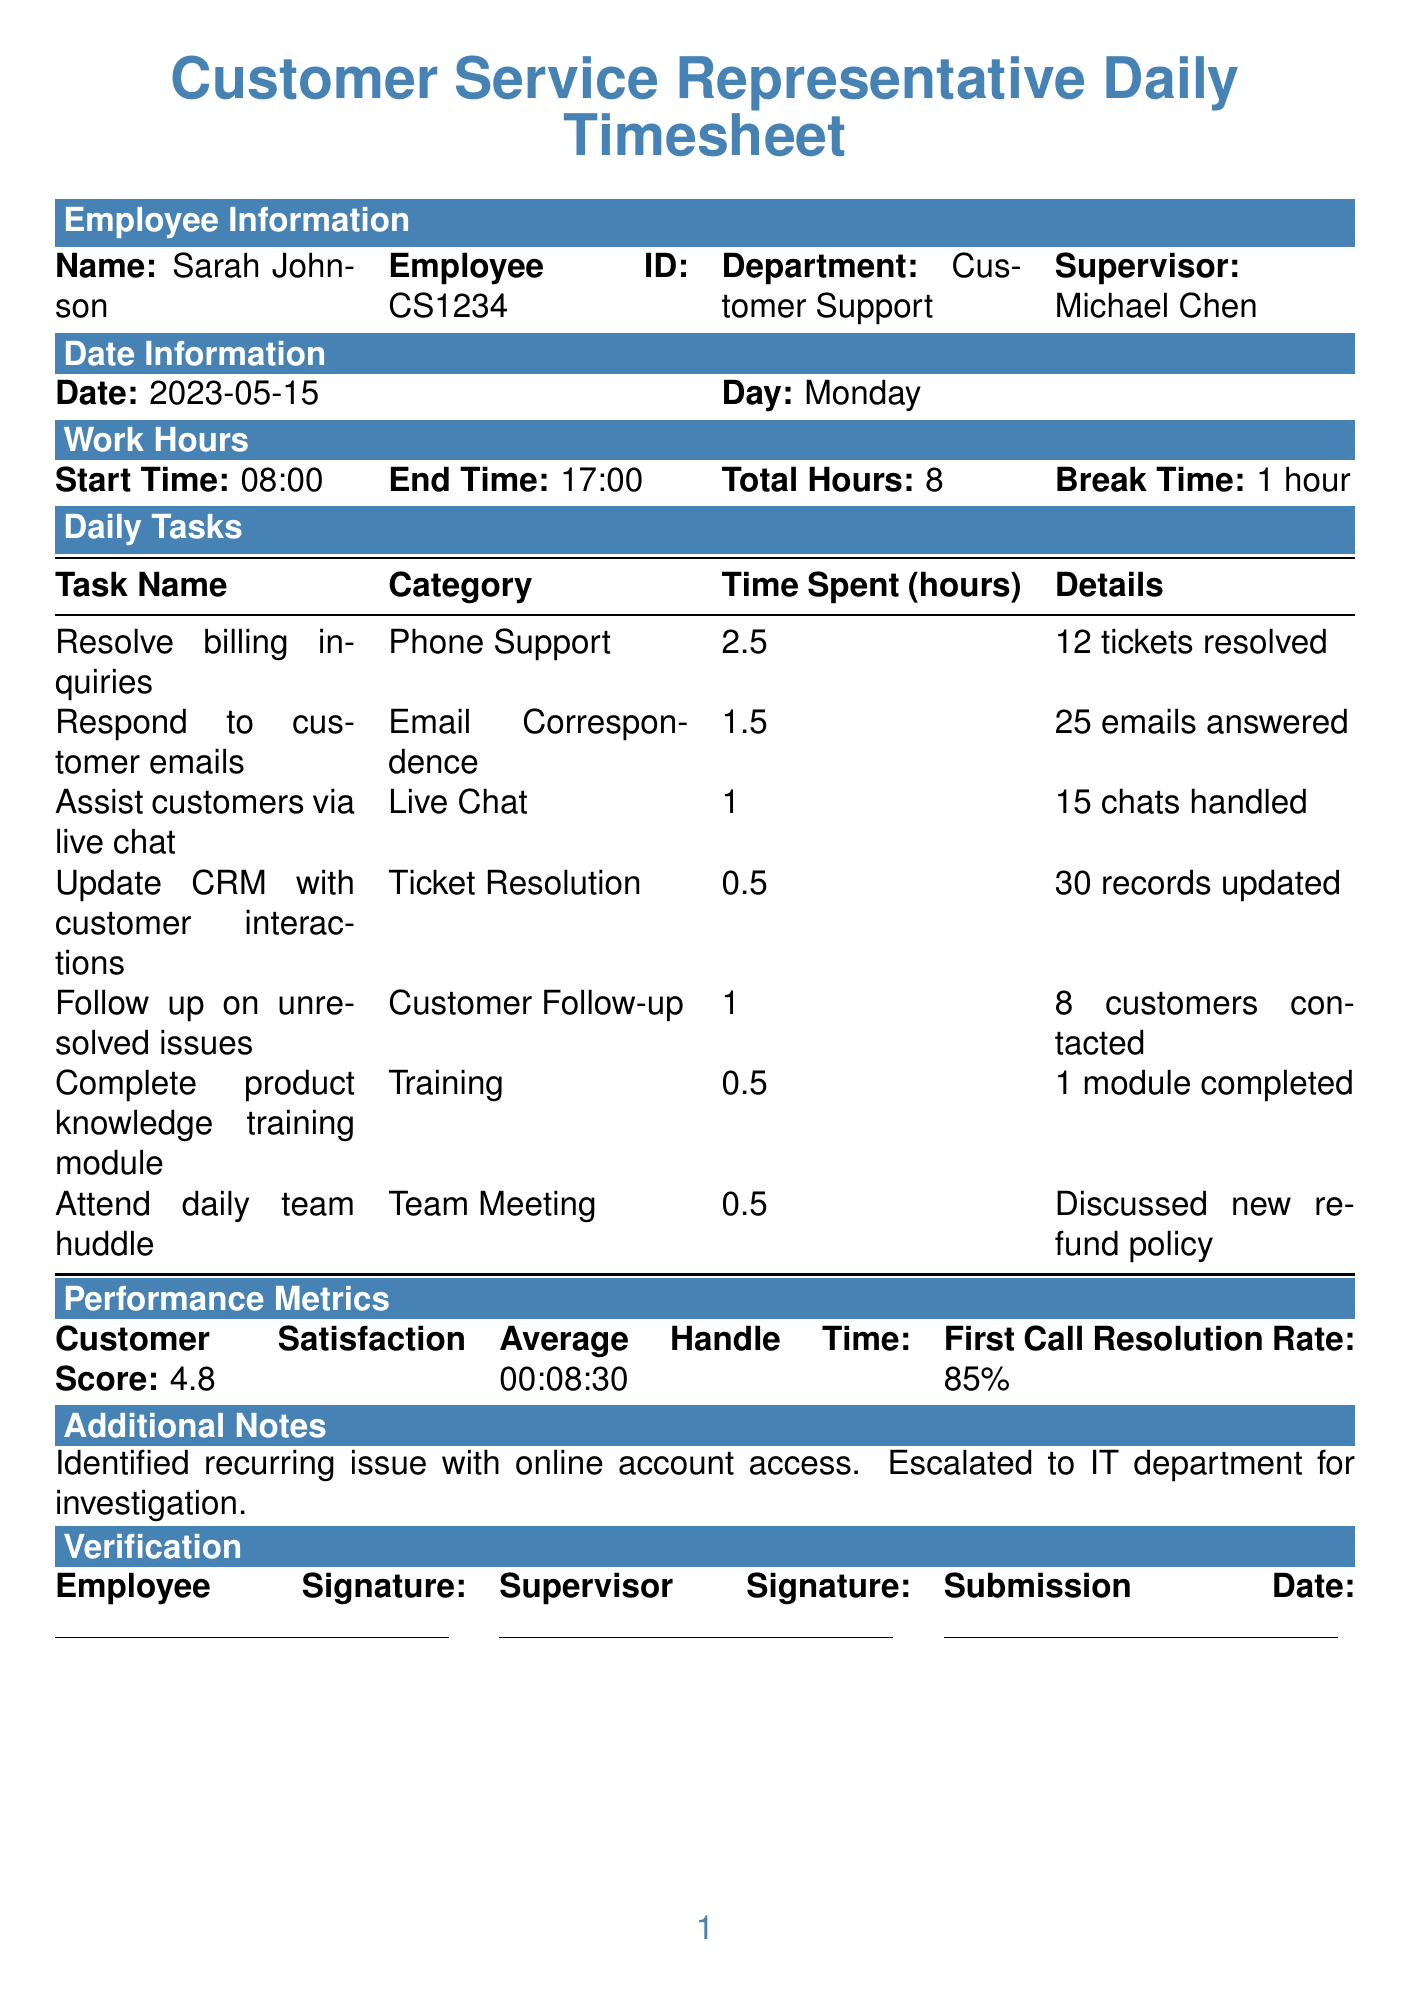What is the employee's name? The employee's name is clearly stated in the document under Employee Information.
Answer: Sarah Johnson How many total hours did Sarah work? Total hours worked is provided in the Work Hours section of the document.
Answer: 8 What was the customer satisfaction score? The customer satisfaction score is noted in the Performance Metrics section.
Answer: 4.8 Which task took the longest time? To find the task with the longest time spent, we compare the timeSpent values in the Daily Tasks section.
Answer: Resolve billing inquiries How many tickets did Sarah resolve? The number of tickets resolved is included in the task details for billing inquiries under Daily Tasks.
Answer: 12 How long was the break taken? The break time is specified in the Work Hours section of the document.
Answer: 1 hour What was discussed in the daily team huddle? The notes from the team meeting are provided in the Daily Tasks section.
Answer: Discussed new refund policy What is the average handle time? The average handle time is specified in the Performance Metrics section of the document.
Answer: 00:08:30 How many customers were contacted for follow-up? This number can be found in the Daily Tasks under the Customer Follow-up category.
Answer: 8 